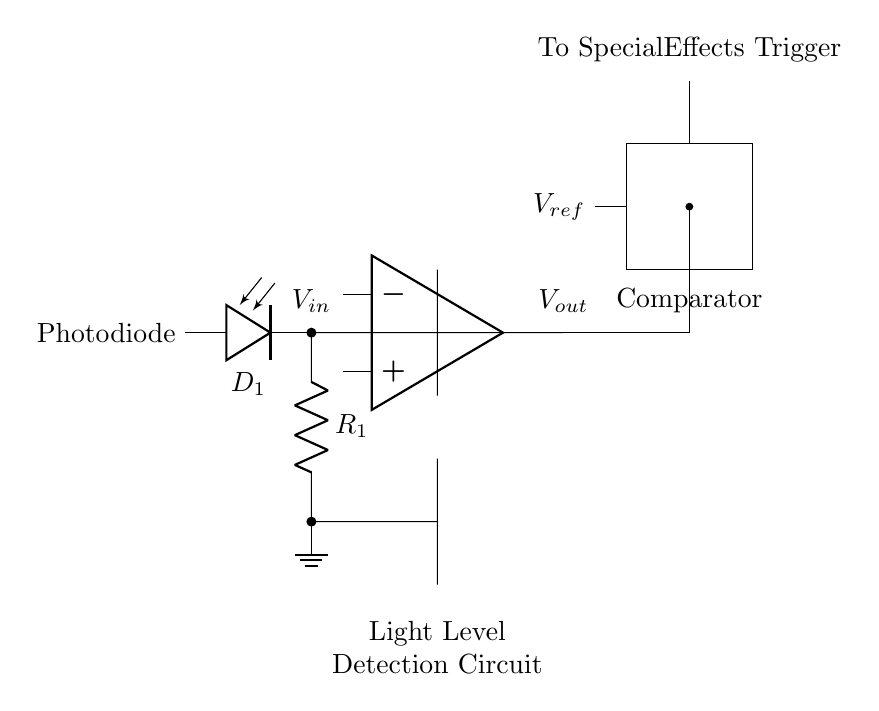What is the component labeled as D1? D1 is the photodiode, which is used to convert light into an electrical signal. It is indicated in the circuit as the first component connected at the start.
Answer: photodiode What is the function of the resistor R1? R1 serves as a load resistor in the circuit, helping to limit the current flowing through the photodiode and setting the gain for the operational amplifier. Its placement after the photodiode confirms its role in the signal conditioning stage.
Answer: load resistor What does Vout represent? Vout represents the output voltage from the operational amplifier, which indicates the processed output signal based on the input light levels detected by the photodiode. It is the voltage that will ultimately trigger the special effects.
Answer: output voltage What does Vref indicate in the comparator? Vref is the reference voltage that the output signal is compared against to determine if the light levels exceed a certain threshold, triggering the special effects. This voltage is crucial for the comparator’s operation.
Answer: reference voltage How does the circuit trigger special effects? The output from the operational amplifier is sent to the comparator, which checks if the voltage level exceeds Vref; when it does, the output triggers the special effects. This involves a combination of light detection and electrical signal processing to activate effects.
Answer: voltage comparison What is the role of the comparator in this circuit? The comparator compares the output voltage from the operational amplifier against the reference voltage Vref to determine if a certain light level has been reached, then signals to activate the special effects accordingly.
Answer: light level comparison What is the significance of grounding in this circuit? Grounding provides a common reference point for all components in the circuit, ensuring stability and proper functioning of the components, particularly affecting the operation of the operational amplifier and comparator.
Answer: common reference 